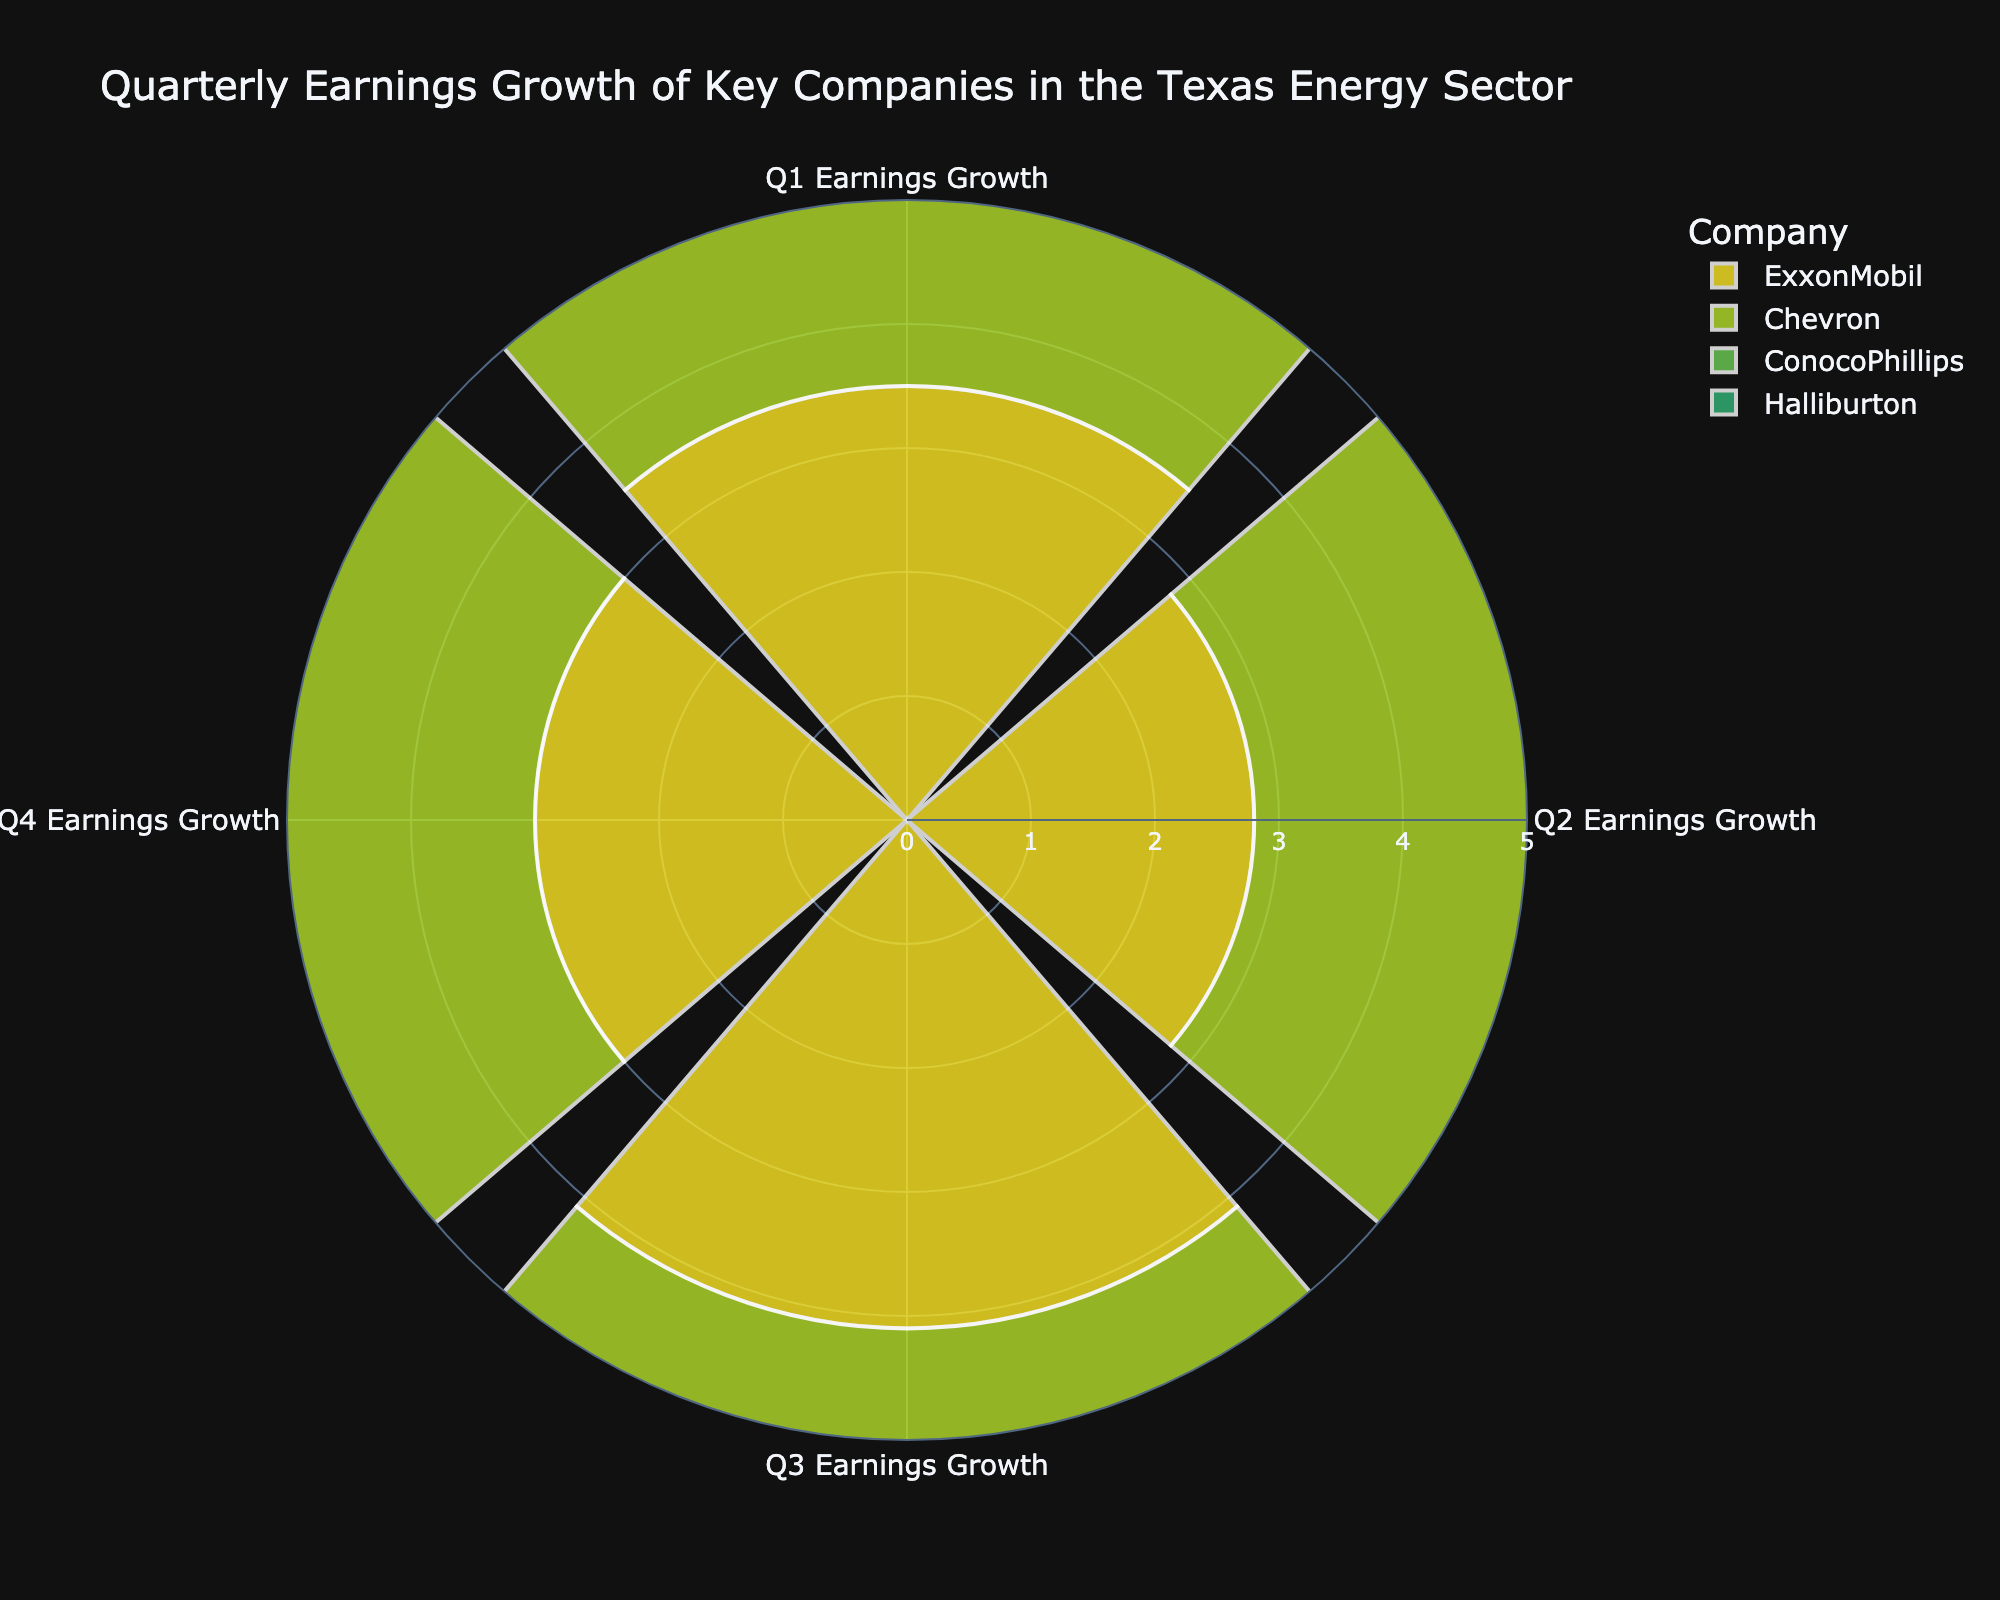What is the title of the figure? The title is usually prominently displayed at the top of the figure. In this case, it should clearly state the subject being portrayed.
Answer: "Quarterly Earnings Growth of Key Companies in the Texas Energy Sector" Which company had the highest earnings growth in Q3? To answer this, locate the Q3 section in the rose chart and identify the company with the longest segment.
Answer: ConocoPhillips Compare the Q4 earnings growth of ExxonMobil and Chevron. Which company had higher growth? Find the Q4 sections in the rose chart for both ExxonMobil and Chevron and compare the lengths of their segments.
Answer: ConocoPhillips How does ConocoPhillips' Q2 earnings growth compare with Halliburton's Q2 earnings growth? Locate the Q2 segments for both ConocoPhillips and Halliburton in the rose chart and compare their lengths.
Answer: ConocoPhillips has higher growth What is the average earnings growth for Chevron across all quarters? Sum the quarterly earnings growth values for Chevron and divide by the number of quarters (4). Sum: 4.0 + 3.2 + 3.8 + 3.5 = 14.5. Average: 14.5/4.
Answer: 3.625 Which company showed the most consistent quarterly earnings growth in 2023? Consistency implies the least variation in the length of segments across quarters. Examine the segments for each company and identify the one with the least difference between their longest and shortest segments.
Answer: Halliburton What is the difference in Q1 earnings growth between ExxonMobil and ConocoPhillips? Locate the Q1 segments for ExxonMobil and ConocoPhillips in the rose chart, then subtract the smaller value from the larger one for Q1 earnings growth. Difference: 3.5 - 2.7.
Answer: 0.8 Which quarter had the highest overall earnings growth across all companies? Sum the earnings growth values for each quarter across all companies and compare. The quarter with the highest sum has the highest overall growth. Sum for Q1: 3.5+4.0+2.7+2.9 = 13.1, Q2: 2.8+3.2+3.5+3.0 = 12.5, Q3: 4.1+3.8+4.4+3.6 = 15.9, Q4: 3.0+3.5+3.8+3.3 = 13.6.
Answer: Q3 Which company had the lowest earnings growth in Q2? Locate the Q2 section in the rose chart and identify the company with the shortest segment.
Answer: ExxonMobil 